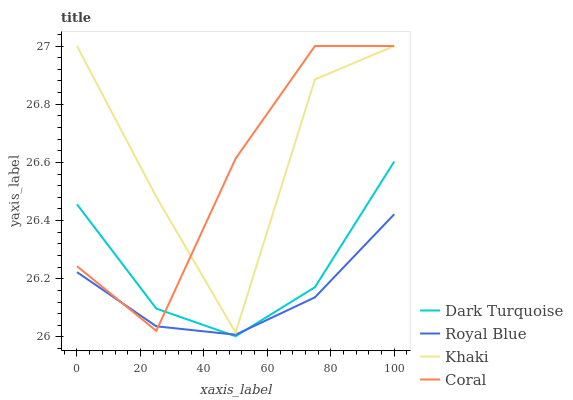Does Royal Blue have the minimum area under the curve?
Answer yes or no. Yes. Does Khaki have the maximum area under the curve?
Answer yes or no. Yes. Does Coral have the minimum area under the curve?
Answer yes or no. No. Does Coral have the maximum area under the curve?
Answer yes or no. No. Is Royal Blue the smoothest?
Answer yes or no. Yes. Is Khaki the roughest?
Answer yes or no. Yes. Is Coral the smoothest?
Answer yes or no. No. Is Coral the roughest?
Answer yes or no. No. Does Dark Turquoise have the lowest value?
Answer yes or no. Yes. Does Khaki have the lowest value?
Answer yes or no. No. Does Khaki have the highest value?
Answer yes or no. Yes. Does Royal Blue have the highest value?
Answer yes or no. No. Is Royal Blue less than Khaki?
Answer yes or no. Yes. Is Khaki greater than Royal Blue?
Answer yes or no. Yes. Does Royal Blue intersect Coral?
Answer yes or no. Yes. Is Royal Blue less than Coral?
Answer yes or no. No. Is Royal Blue greater than Coral?
Answer yes or no. No. Does Royal Blue intersect Khaki?
Answer yes or no. No. 